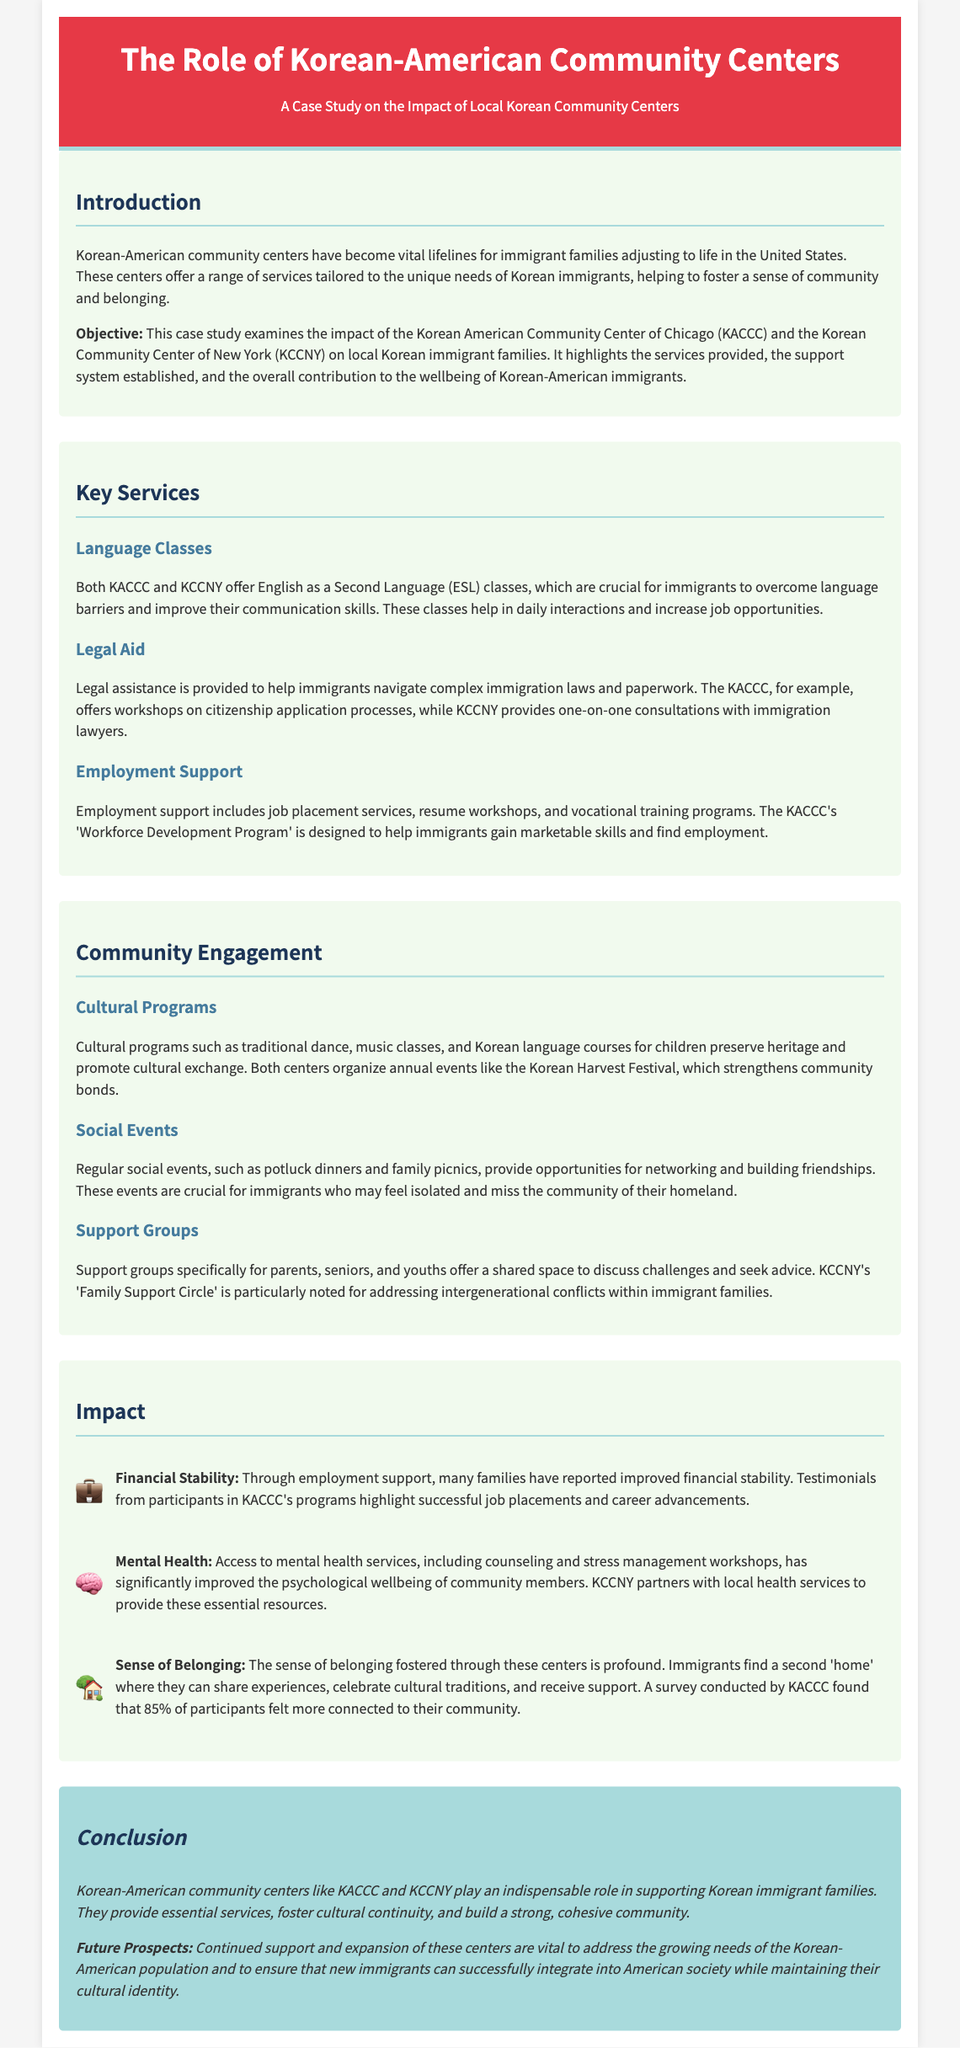What is the primary objective of the case study? The case study examines the impact of the Korean American Community Center of Chicago and the Korean Community Center of New York on local Korean immigrant families, highlighting services provided and overall contributions.
Answer: Impact of local Korean immigrant families How many family support circles are mentioned in the document? KCCNY's 'Family Support Circle' is specifically noted for addressing intergenerational conflicts within immigrant families.
Answer: One What are the two main community centers mentioned? The document specifically names KACCC and KCCNY as the primary community centers being analyzed in the case study.
Answer: KACCC and KCCNY What support is provided related to employment? Employment support includes job placement services, resume workshops, and vocational training programs.
Answer: Job placement services What percentage of participants felt more connected to their community? A survey conducted by KACCC found that 85% of participants felt more connected to their community.
Answer: 85% Which cultural event is organized by both centers? The centers organize annual events like the Korean Harvest Festival, which strengthens community bonds.
Answer: Korean Harvest Festival What type of classes do KACCC and KCCNY offer? Both KACCC and KCCNY offer English as a Second Language (ESL) classes.
Answer: ESL classes What role do community centers play in mental health? Access to mental health services, including counseling and stress management workshops, has significantly improved the psychological wellbeing of community members.
Answer: Improved psychological wellbeing 